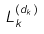<formula> <loc_0><loc_0><loc_500><loc_500>L _ { k } ^ { ( d _ { k } ) }</formula> 